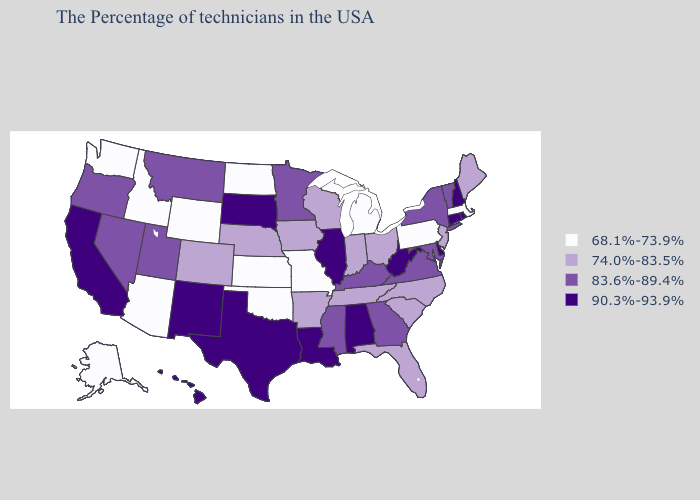Does Missouri have the same value as North Dakota?
Quick response, please. Yes. What is the value of Tennessee?
Be succinct. 74.0%-83.5%. Does the first symbol in the legend represent the smallest category?
Keep it brief. Yes. Does Louisiana have the highest value in the South?
Quick response, please. Yes. What is the value of Idaho?
Answer briefly. 68.1%-73.9%. Does Colorado have the same value as Maine?
Give a very brief answer. Yes. What is the highest value in the Northeast ?
Quick response, please. 90.3%-93.9%. Does the map have missing data?
Be succinct. No. Among the states that border Pennsylvania , which have the highest value?
Write a very short answer. Delaware, West Virginia. Among the states that border West Virginia , which have the highest value?
Write a very short answer. Maryland, Virginia, Kentucky. Name the states that have a value in the range 68.1%-73.9%?
Quick response, please. Massachusetts, Pennsylvania, Michigan, Missouri, Kansas, Oklahoma, North Dakota, Wyoming, Arizona, Idaho, Washington, Alaska. Name the states that have a value in the range 68.1%-73.9%?
Answer briefly. Massachusetts, Pennsylvania, Michigan, Missouri, Kansas, Oklahoma, North Dakota, Wyoming, Arizona, Idaho, Washington, Alaska. Among the states that border Arizona , which have the lowest value?
Be succinct. Colorado. Is the legend a continuous bar?
Answer briefly. No. What is the highest value in the USA?
Quick response, please. 90.3%-93.9%. 